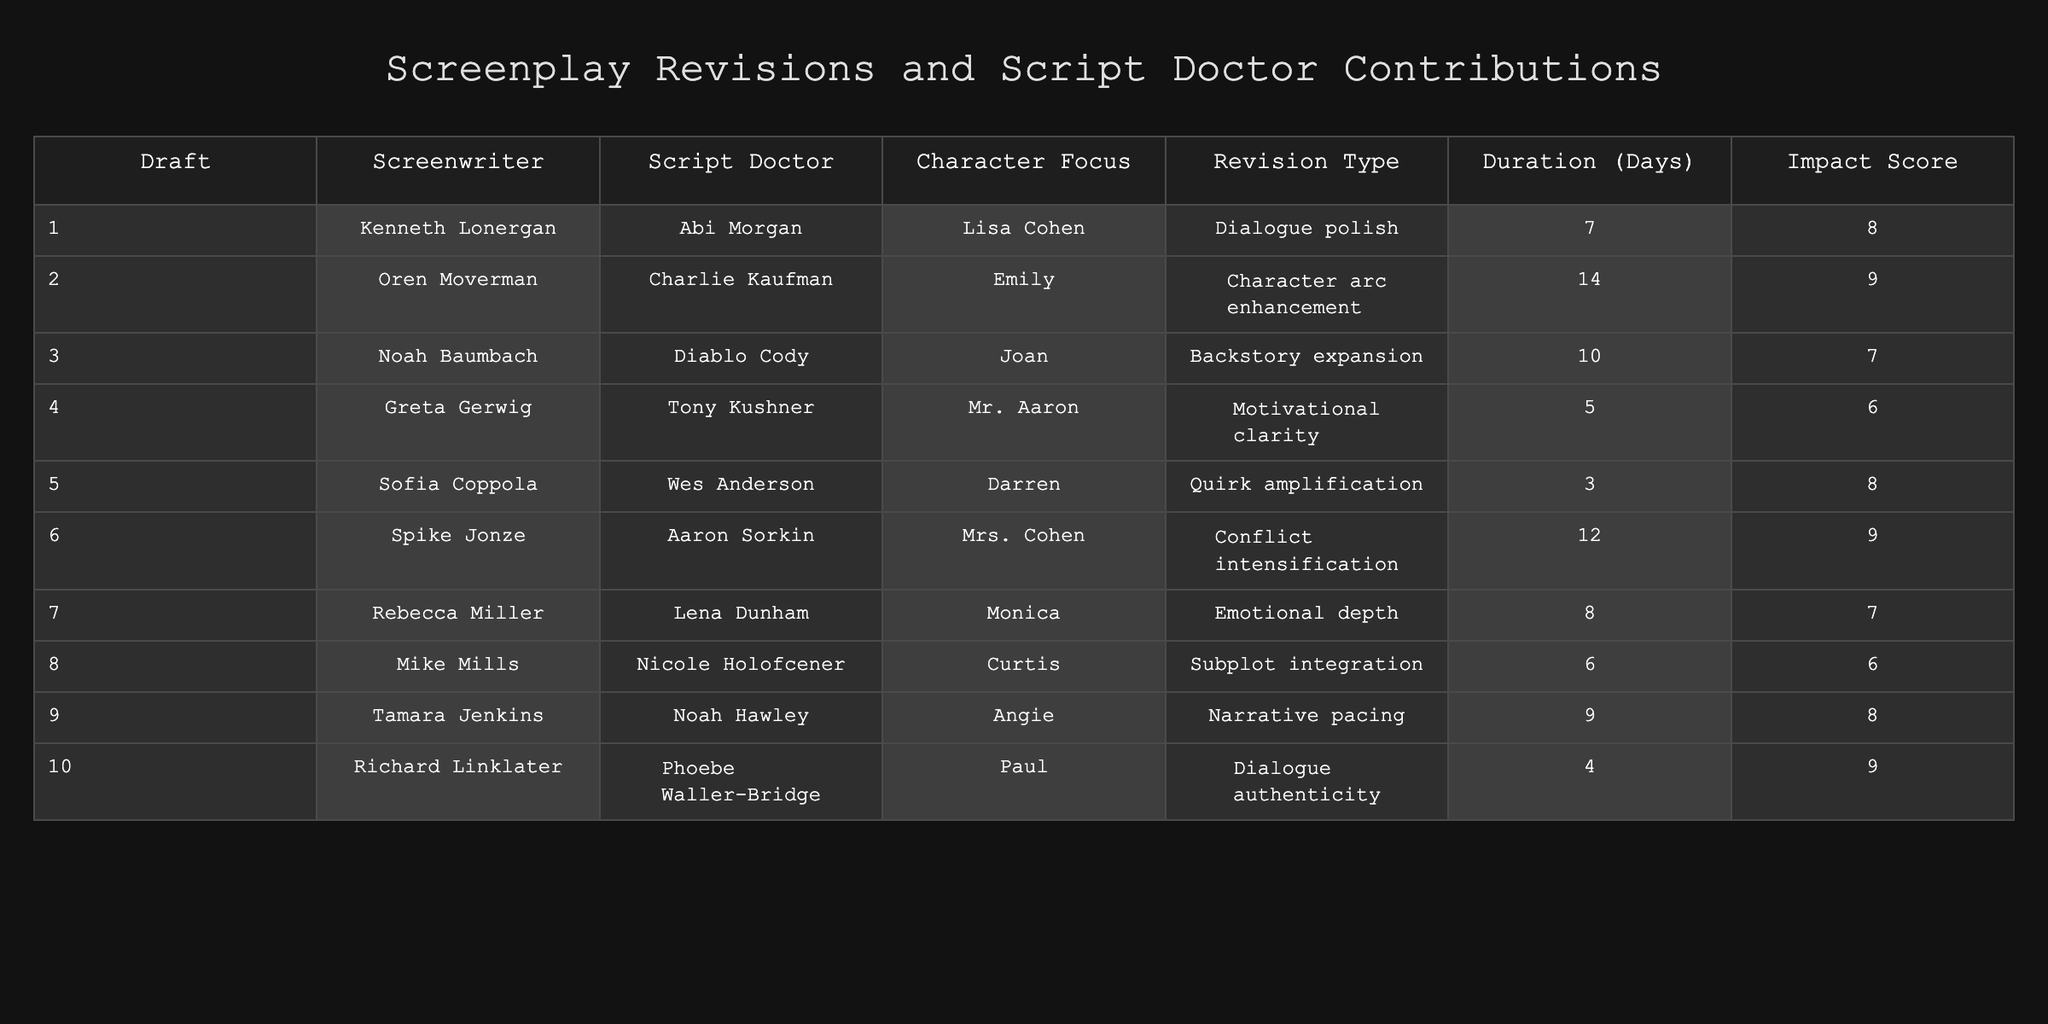What is the impact score for the screenplay revision of Draft 3? The impact score for Draft 3, focused on the character Joan, is listed in the table under "Impact Score" which shows a value of 7.
Answer: 7 Which screenplay revision took the longest duration? By looking at the "Duration (Days)" column, Draft 2 shows the longest duration of 14 days.
Answer: 14 days Is there a draft written by Kenneth Lonergan? Yes, the table shows that Draft 1 was written by Kenneth Lonergan.
Answer: Yes What type of revision was made for Draft 6? The type of revision for Draft 6 is "Conflict intensification," as indicated in the "Revision Type" column.
Answer: Conflict intensification What is the average impact score for all drafts? Summing the impact scores (8 + 9 + 7 + 6 + 8 + 9 + 7 + 6 + 8 + 9) gives 78. There are 10 drafts, thus the average is 78/10 = 7.8.
Answer: 7.8 Which character received the most thorough revision based on impact score? The characters with the highest impact score are Emily from Draft 2 and Mrs. Cohen from Draft 6, both having an impact score of 9.
Answer: Emily and Mrs. Cohen How many drafts focused on emotional depth for characters? Draft 7 is the only one specifically noted to focus on "Emotional depth."
Answer: 1 Which screenplay revision was completed in the shortest duration, and who contributed as script doctor? Draft 5 was completed in the shortest duration of 3 days, and it had Wes Anderson as the script doctor.
Answer: 3 days, Wes Anderson What is the difference between the highest and lowest impact scores? The highest impact score is 9 (from Drafts 2, 6, and 10) and the lowest is 6 (from Drafts 4 and 8). The difference is 9 - 6 = 3.
Answer: 3 Was there any draft associated with character quirk amplification, and if so, who contributed? Yes, Draft 5 is associated with quirk amplification, with Wes Anderson contributing as the script doctor.
Answer: Yes, Wes Anderson 